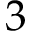<formula> <loc_0><loc_0><loc_500><loc_500>3</formula> 